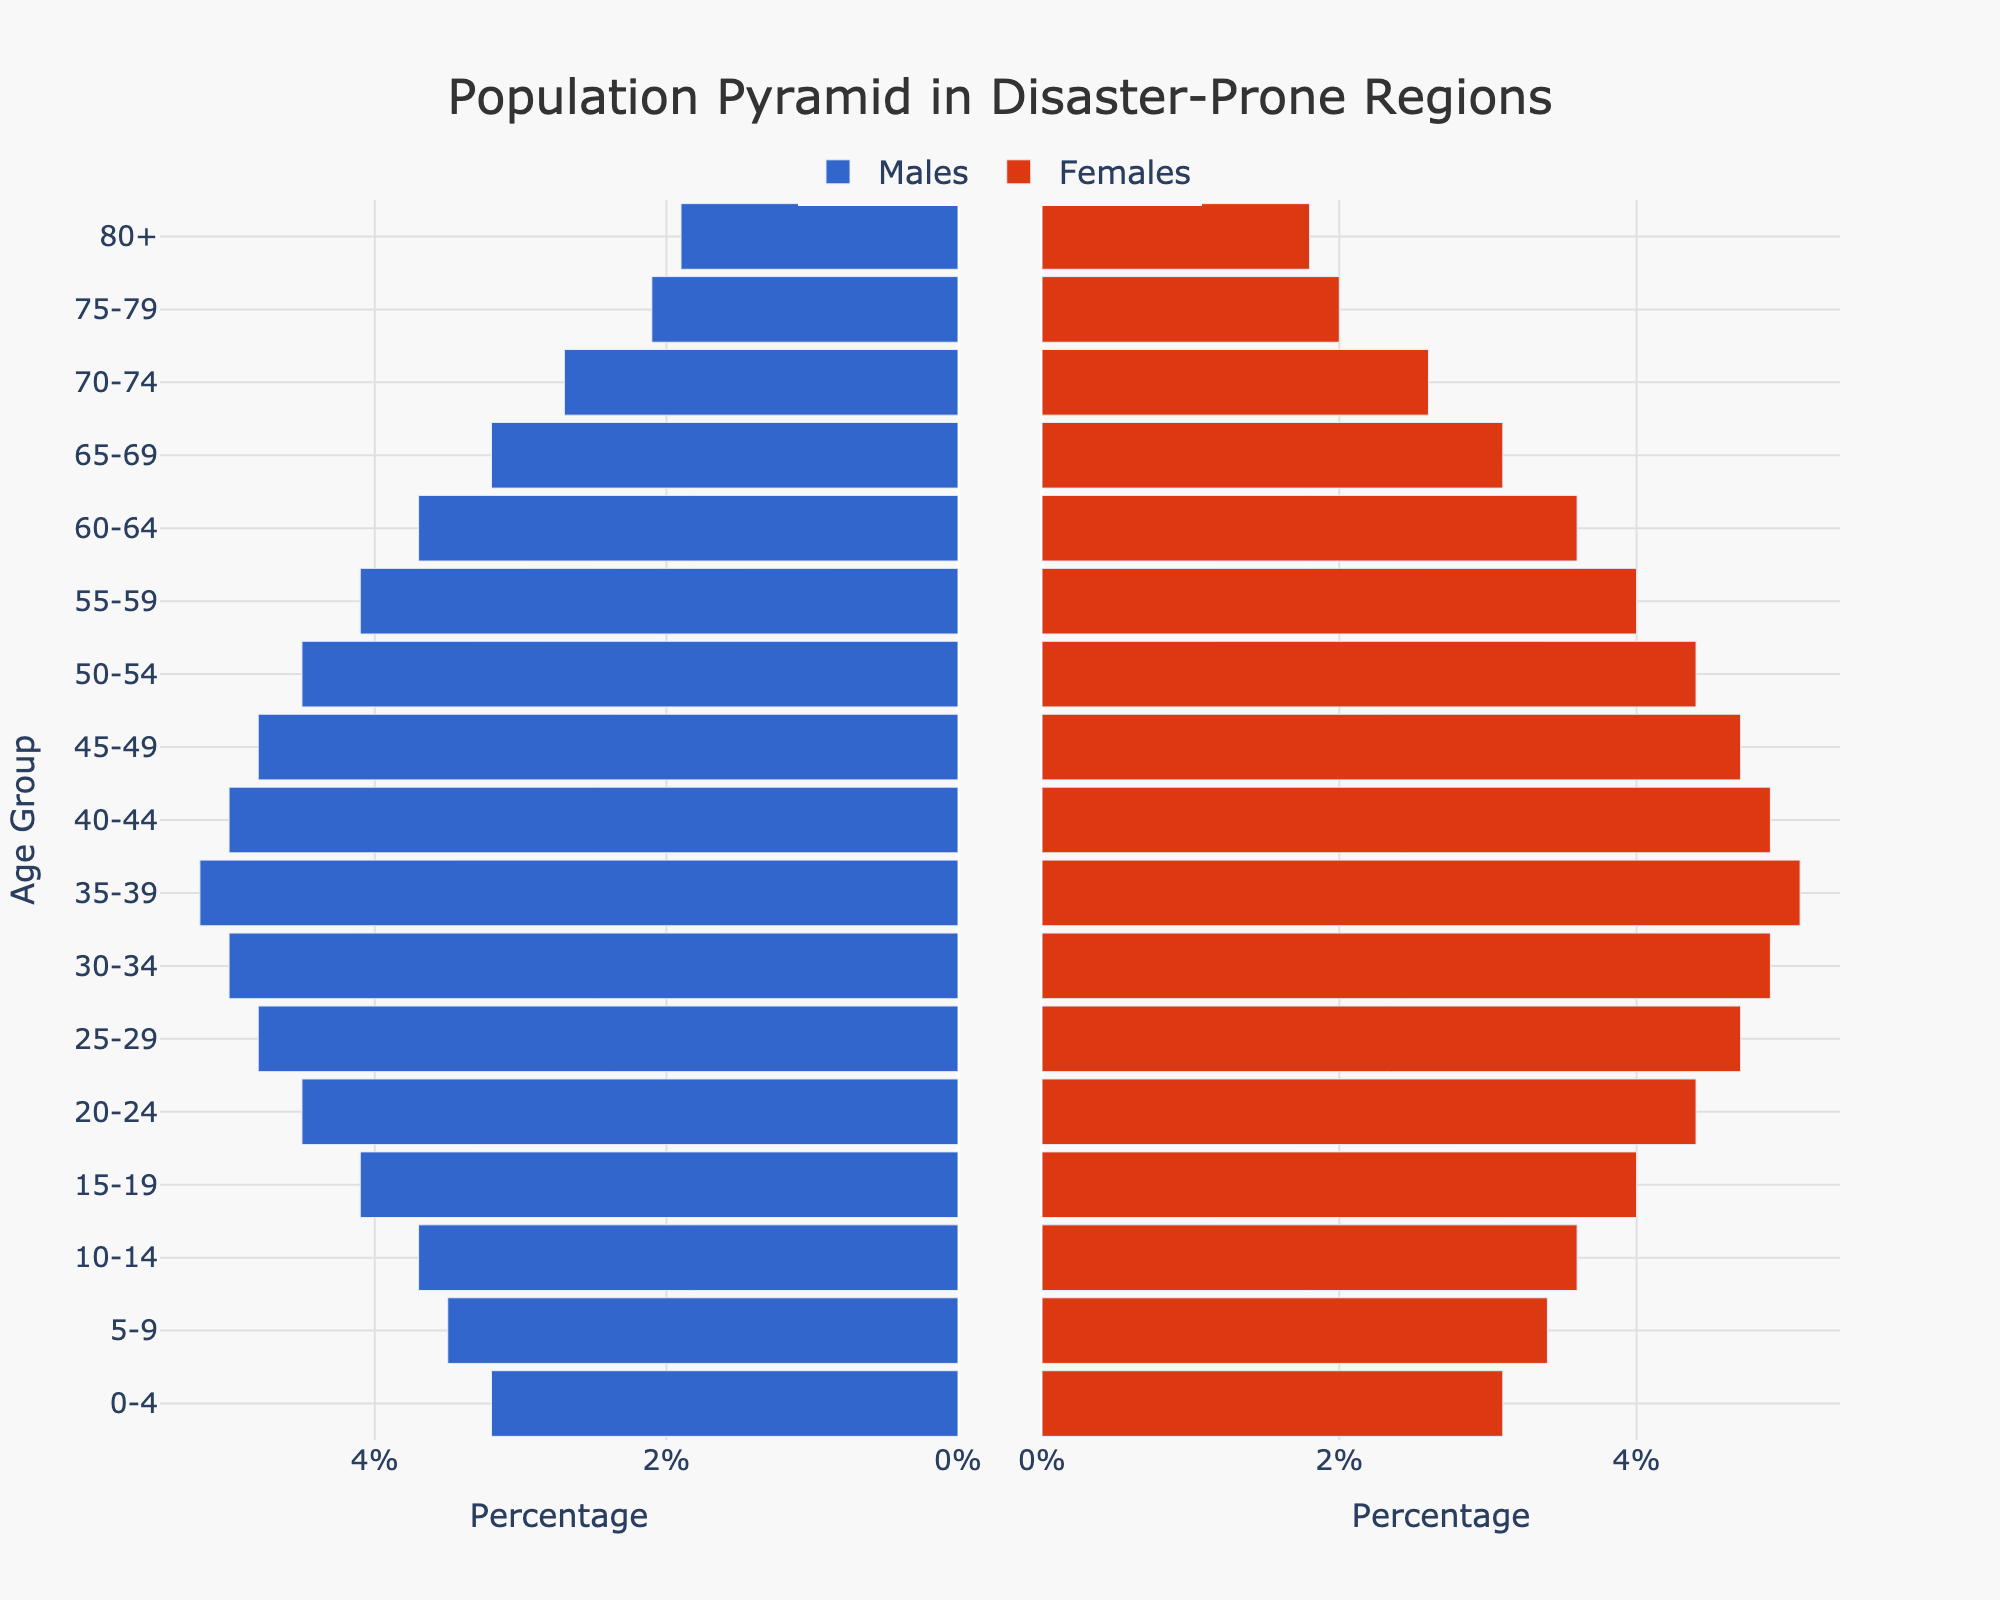What is the title of the figure? The title is usually presented prominently at the top of the figure. By referring to the top section, a viewer can find the title.
Answer: Population Pyramid in Disaster-Prone Regions What does the x-axis represent on the left side of the pyramid? The x-axis on the left side is labeled with ticks such as '6%', '4%', '2%', and '0%', which represent the percentage of the male population in each age group.
Answer: Percentage of Males Which age group has the largest percentage of males? By examining the bars on the left side of the pyramid, the longest bar corresponds to the age group with the largest percentage of males.
Answer: 35-39 Compare the percentages of males and females in the 25-29 age group. Observing both sides of the figure for the 25-29 age group, we compare the lengths of the bars (or specified percentages).
Answer: Males: 4.8%, Females: 4.7% What is the combined percentage of the population aged 10-14? Summing up the percentages of males and females from the 10-14 age group to find the total percentage.
Answer: 7.3% Describe the trend in population percentage as age increases from 0-4 to 80+ for females. Observing the female side of the pyramid, we see that the bar lengths generally decrease as age increases, indicating a reduction in percentage.
Answer: Decreasing trend How does the population percentage of males aged 60-64 compare to that of females in the same age group? Looking at the lengths of the bars for the age group 60-64, we see the values are 3.7% for both males and females, showing they are equal.
Answer: They are equal Which gender has a higher percentage in the age group 70-74? By comparing the lengths of the bars for the age group 70-74, we notice that males have a slightly higher bar length.
Answer: Males Are there more males or females in the 0-4 age group? Comparing the bar lengths for both genders in the 0-4 age group reveals that males have a slightly longer bar.
Answer: Males Identify the age group where the gender discrepancy is the most noticeable. Observing the bars for both genders across all age groups, we notice that the age group 35-39 shows the most noticeable discrepancy in favor of males.
Answer: 35-39 